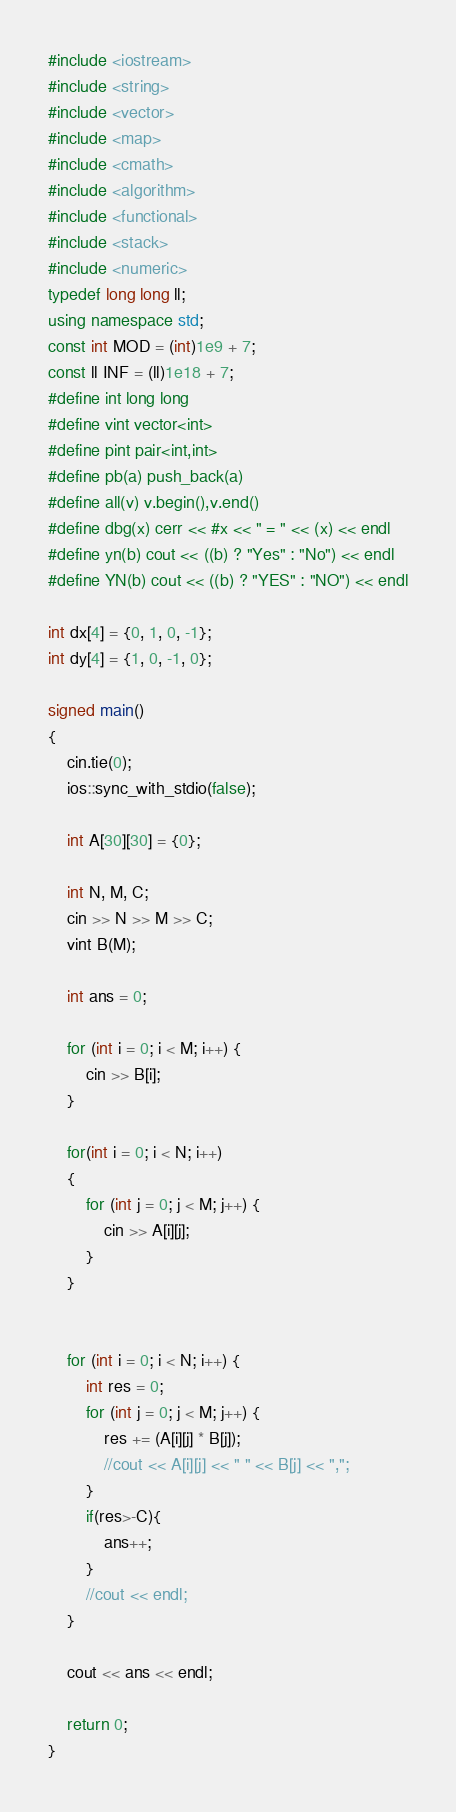<code> <loc_0><loc_0><loc_500><loc_500><_C++_>#include <iostream>
#include <string>
#include <vector>
#include <map>
#include <cmath>
#include <algorithm>
#include <functional>
#include <stack>
#include <numeric>
typedef long long ll;
using namespace std;
const int MOD = (int)1e9 + 7;
const ll INF = (ll)1e18 + 7;
#define int long long
#define vint vector<int>
#define pint pair<int,int>
#define pb(a) push_back(a)
#define all(v) v.begin(),v.end()
#define dbg(x) cerr << #x << " = " << (x) << endl
#define yn(b) cout << ((b) ? "Yes" : "No") << endl
#define YN(b) cout << ((b) ? "YES" : "NO") << endl

int dx[4] = {0, 1, 0, -1};
int dy[4] = {1, 0, -1, 0};

signed main()
{
	cin.tie(0);
	ios::sync_with_stdio(false);

	int A[30][30] = {0};

	int N, M, C;
	cin >> N >> M >> C;
	vint B(M);

	int ans = 0;

	for (int i = 0; i < M; i++) {
		cin >> B[i];
	}

	for(int i = 0; i < N; i++)
	{
		for (int j = 0; j < M; j++) {
			cin >> A[i][j];
		}
	}
	

	for (int i = 0; i < N; i++) {
		int res = 0;
		for (int j = 0; j < M; j++) {
			res += (A[i][j] * B[j]);
			//cout << A[i][j] << " " << B[j] << ",";
		}
		if(res>-C){
			ans++;
		}
		//cout << endl;
	}

	cout << ans << endl;

	return 0;
}</code> 